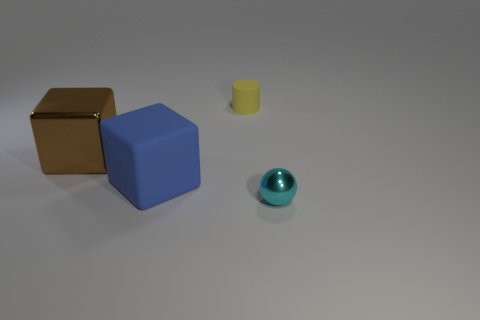Are the brown block and the small object in front of the blue block made of the same material?
Your answer should be compact. Yes. Are there more metal blocks than tiny green matte objects?
Provide a succinct answer. Yes. What number of spheres are either blue things or tiny things?
Offer a terse response. 1. What is the color of the rubber cylinder?
Ensure brevity in your answer.  Yellow. Do the metallic thing that is to the left of the sphere and the matte object to the left of the yellow cylinder have the same size?
Your answer should be very brief. Yes. Are there fewer small cyan things than tiny blue cylinders?
Give a very brief answer. No. There is a big matte object; how many large brown blocks are right of it?
Offer a terse response. 0. What material is the tiny yellow object?
Give a very brief answer. Rubber. Is the tiny shiny ball the same color as the cylinder?
Keep it short and to the point. No. Is the number of small cyan shiny objects that are in front of the sphere less than the number of yellow matte cylinders?
Your answer should be very brief. Yes. 